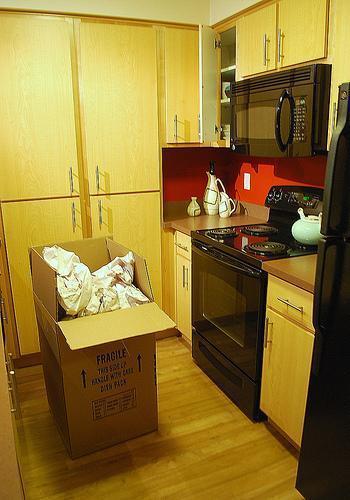How many pitchers are in the corner?
Give a very brief answer. 3. How many outlets are visible?
Give a very brief answer. 1. 